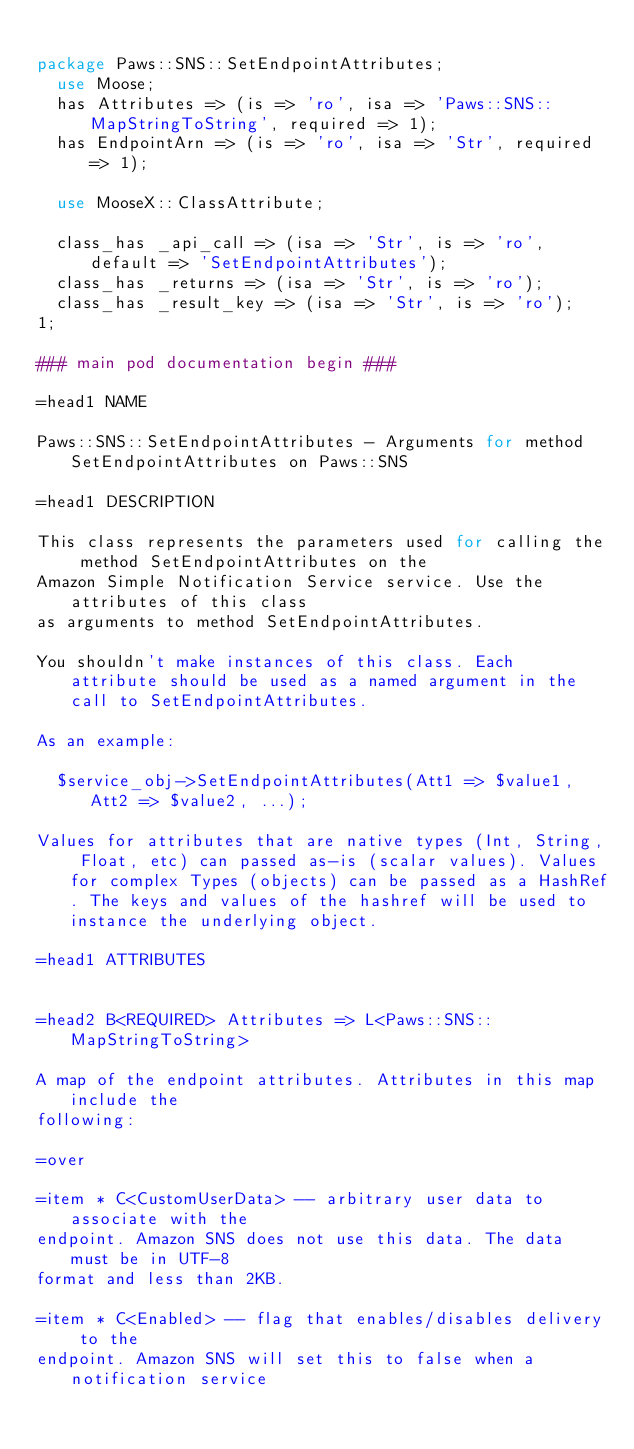<code> <loc_0><loc_0><loc_500><loc_500><_Perl_>
package Paws::SNS::SetEndpointAttributes;
  use Moose;
  has Attributes => (is => 'ro', isa => 'Paws::SNS::MapStringToString', required => 1);
  has EndpointArn => (is => 'ro', isa => 'Str', required => 1);

  use MooseX::ClassAttribute;

  class_has _api_call => (isa => 'Str', is => 'ro', default => 'SetEndpointAttributes');
  class_has _returns => (isa => 'Str', is => 'ro');
  class_has _result_key => (isa => 'Str', is => 'ro');
1;

### main pod documentation begin ###

=head1 NAME

Paws::SNS::SetEndpointAttributes - Arguments for method SetEndpointAttributes on Paws::SNS

=head1 DESCRIPTION

This class represents the parameters used for calling the method SetEndpointAttributes on the 
Amazon Simple Notification Service service. Use the attributes of this class
as arguments to method SetEndpointAttributes.

You shouldn't make instances of this class. Each attribute should be used as a named argument in the call to SetEndpointAttributes.

As an example:

  $service_obj->SetEndpointAttributes(Att1 => $value1, Att2 => $value2, ...);

Values for attributes that are native types (Int, String, Float, etc) can passed as-is (scalar values). Values for complex Types (objects) can be passed as a HashRef. The keys and values of the hashref will be used to instance the underlying object.

=head1 ATTRIBUTES


=head2 B<REQUIRED> Attributes => L<Paws::SNS::MapStringToString>

A map of the endpoint attributes. Attributes in this map include the
following:

=over

=item * C<CustomUserData> -- arbitrary user data to associate with the
endpoint. Amazon SNS does not use this data. The data must be in UTF-8
format and less than 2KB.

=item * C<Enabled> -- flag that enables/disables delivery to the
endpoint. Amazon SNS will set this to false when a notification service</code> 